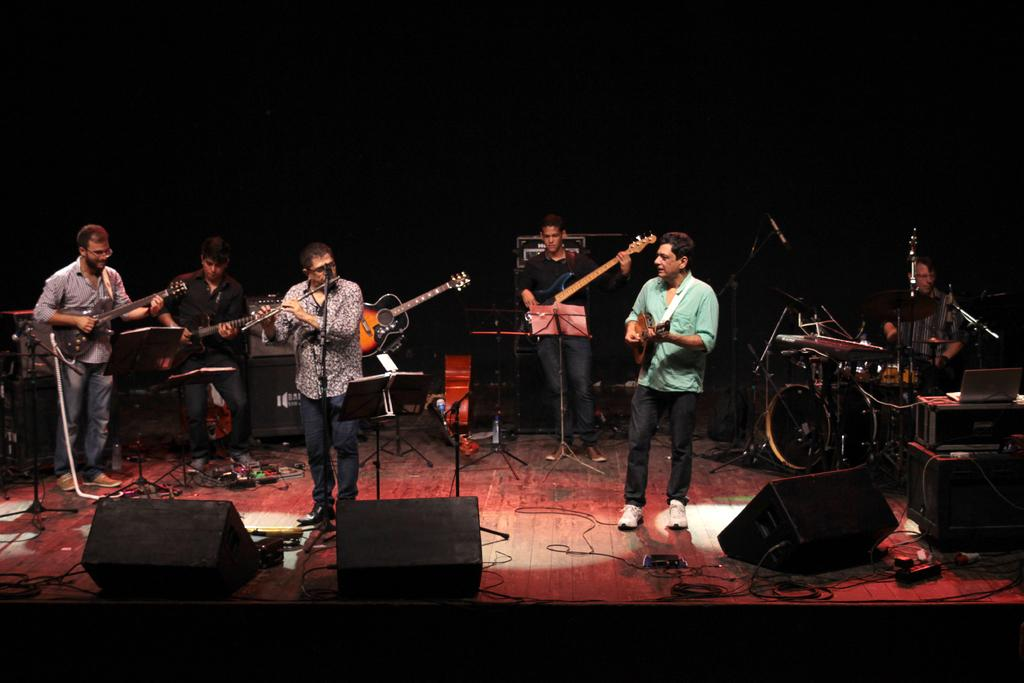What are the persons on the stage doing? The persons on the stage are playing guitars. What type of objects can be seen in the image besides the persons? There are musical instruments in the image. What type of wave can be seen in the image? There is no wave present in the image; it features persons playing guitars on a stage. 